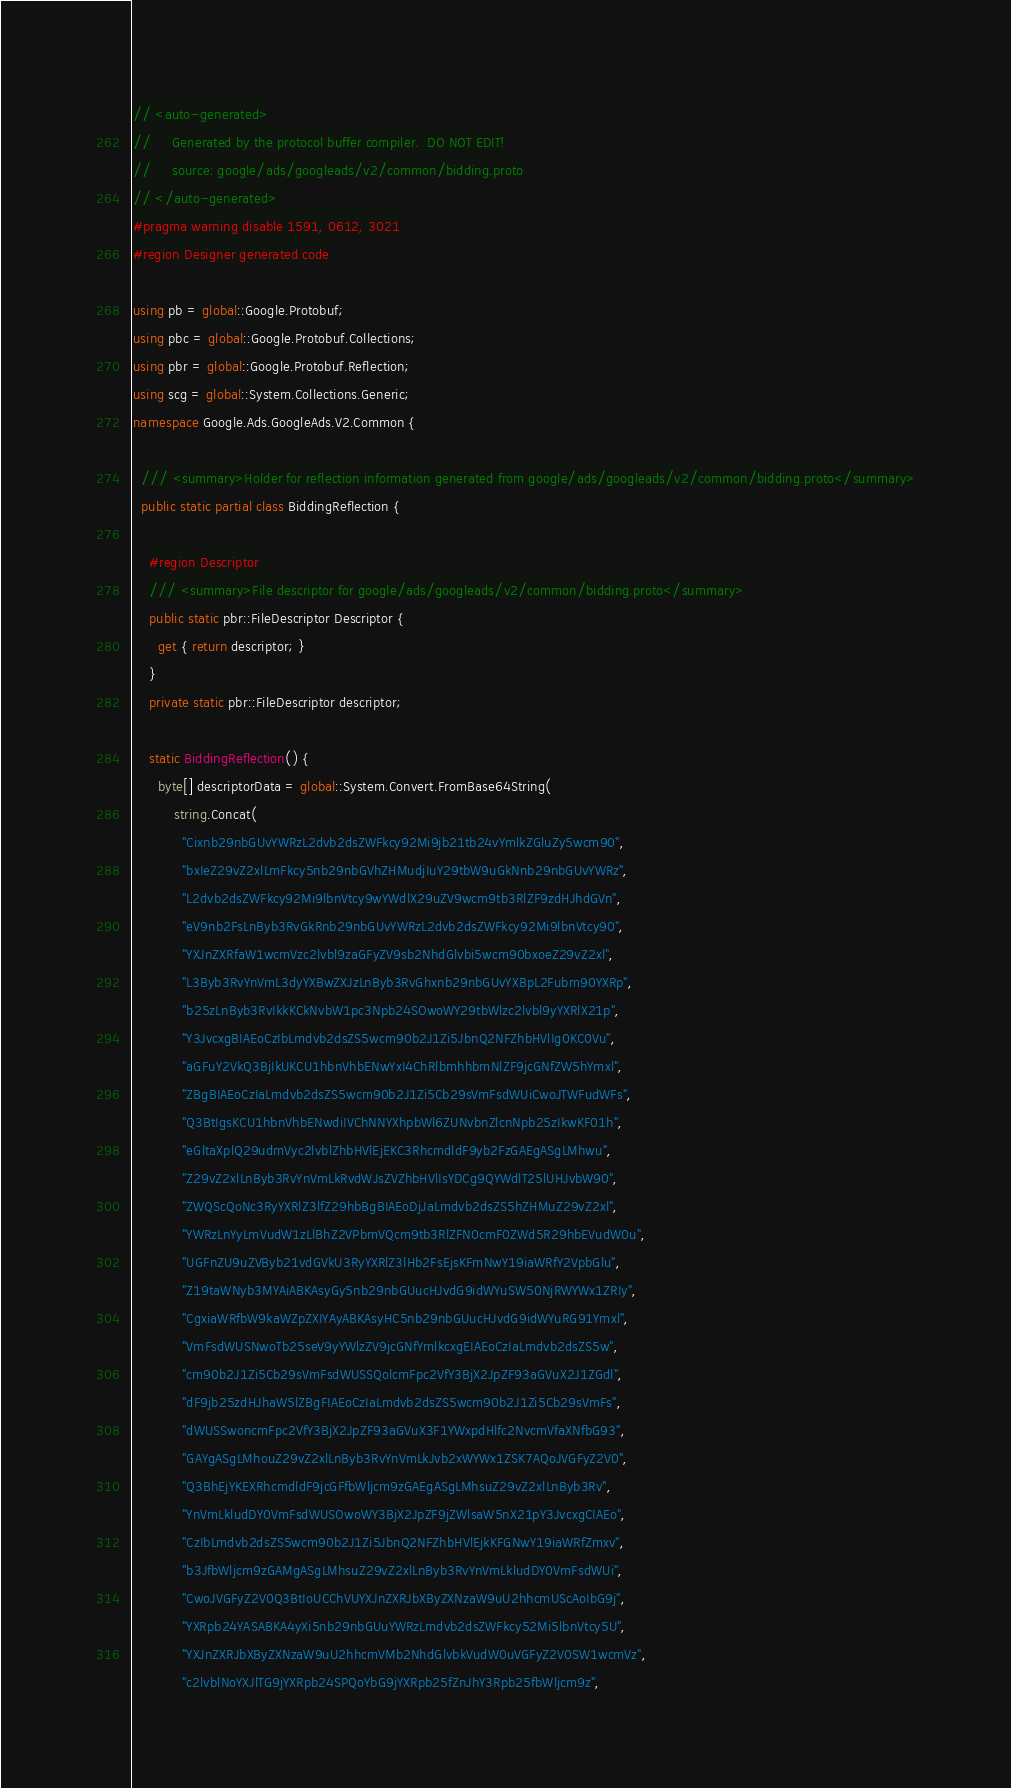Convert code to text. <code><loc_0><loc_0><loc_500><loc_500><_C#_>// <auto-generated>
//     Generated by the protocol buffer compiler.  DO NOT EDIT!
//     source: google/ads/googleads/v2/common/bidding.proto
// </auto-generated>
#pragma warning disable 1591, 0612, 3021
#region Designer generated code

using pb = global::Google.Protobuf;
using pbc = global::Google.Protobuf.Collections;
using pbr = global::Google.Protobuf.Reflection;
using scg = global::System.Collections.Generic;
namespace Google.Ads.GoogleAds.V2.Common {

  /// <summary>Holder for reflection information generated from google/ads/googleads/v2/common/bidding.proto</summary>
  public static partial class BiddingReflection {

    #region Descriptor
    /// <summary>File descriptor for google/ads/googleads/v2/common/bidding.proto</summary>
    public static pbr::FileDescriptor Descriptor {
      get { return descriptor; }
    }
    private static pbr::FileDescriptor descriptor;

    static BiddingReflection() {
      byte[] descriptorData = global::System.Convert.FromBase64String(
          string.Concat(
            "Cixnb29nbGUvYWRzL2dvb2dsZWFkcy92Mi9jb21tb24vYmlkZGluZy5wcm90",
            "bxIeZ29vZ2xlLmFkcy5nb29nbGVhZHMudjIuY29tbW9uGkNnb29nbGUvYWRz",
            "L2dvb2dsZWFkcy92Mi9lbnVtcy9wYWdlX29uZV9wcm9tb3RlZF9zdHJhdGVn",
            "eV9nb2FsLnByb3RvGkRnb29nbGUvYWRzL2dvb2dsZWFkcy92Mi9lbnVtcy90",
            "YXJnZXRfaW1wcmVzc2lvbl9zaGFyZV9sb2NhdGlvbi5wcm90bxoeZ29vZ2xl",
            "L3Byb3RvYnVmL3dyYXBwZXJzLnByb3RvGhxnb29nbGUvYXBpL2Fubm90YXRp",
            "b25zLnByb3RvIkkKCkNvbW1pc3Npb24SOwoWY29tbWlzc2lvbl9yYXRlX21p",
            "Y3JvcxgBIAEoCzIbLmdvb2dsZS5wcm90b2J1Zi5JbnQ2NFZhbHVlIg0KC0Vu",
            "aGFuY2VkQ3BjIkUKCU1hbnVhbENwYxI4ChRlbmhhbmNlZF9jcGNfZW5hYmxl",
            "ZBgBIAEoCzIaLmdvb2dsZS5wcm90b2J1Zi5Cb29sVmFsdWUiCwoJTWFudWFs",
            "Q3BtIgsKCU1hbnVhbENwdiIVChNNYXhpbWl6ZUNvbnZlcnNpb25zIkwKF01h",
            "eGltaXplQ29udmVyc2lvblZhbHVlEjEKC3RhcmdldF9yb2FzGAEgASgLMhwu",
            "Z29vZ2xlLnByb3RvYnVmLkRvdWJsZVZhbHVlIsYDCg9QYWdlT25lUHJvbW90",
            "ZWQScQoNc3RyYXRlZ3lfZ29hbBgBIAEoDjJaLmdvb2dsZS5hZHMuZ29vZ2xl",
            "YWRzLnYyLmVudW1zLlBhZ2VPbmVQcm9tb3RlZFN0cmF0ZWd5R29hbEVudW0u",
            "UGFnZU9uZVByb21vdGVkU3RyYXRlZ3lHb2FsEjsKFmNwY19iaWRfY2VpbGlu",
            "Z19taWNyb3MYAiABKAsyGy5nb29nbGUucHJvdG9idWYuSW50NjRWYWx1ZRIy",
            "CgxiaWRfbW9kaWZpZXIYAyABKAsyHC5nb29nbGUucHJvdG9idWYuRG91Ymxl",
            "VmFsdWUSNwoTb25seV9yYWlzZV9jcGNfYmlkcxgEIAEoCzIaLmdvb2dsZS5w",
            "cm90b2J1Zi5Cb29sVmFsdWUSSQolcmFpc2VfY3BjX2JpZF93aGVuX2J1ZGdl",
            "dF9jb25zdHJhaW5lZBgFIAEoCzIaLmdvb2dsZS5wcm90b2J1Zi5Cb29sVmFs",
            "dWUSSwoncmFpc2VfY3BjX2JpZF93aGVuX3F1YWxpdHlfc2NvcmVfaXNfbG93",
            "GAYgASgLMhouZ29vZ2xlLnByb3RvYnVmLkJvb2xWYWx1ZSK7AQoJVGFyZ2V0",
            "Q3BhEjYKEXRhcmdldF9jcGFfbWljcm9zGAEgASgLMhsuZ29vZ2xlLnByb3Rv",
            "YnVmLkludDY0VmFsdWUSOwoWY3BjX2JpZF9jZWlsaW5nX21pY3JvcxgCIAEo",
            "CzIbLmdvb2dsZS5wcm90b2J1Zi5JbnQ2NFZhbHVlEjkKFGNwY19iaWRfZmxv",
            "b3JfbWljcm9zGAMgASgLMhsuZ29vZ2xlLnByb3RvYnVmLkludDY0VmFsdWUi",
            "CwoJVGFyZ2V0Q3BtIoUCChVUYXJnZXRJbXByZXNzaW9uU2hhcmUScAoIbG9j",
            "YXRpb24YASABKA4yXi5nb29nbGUuYWRzLmdvb2dsZWFkcy52Mi5lbnVtcy5U",
            "YXJnZXRJbXByZXNzaW9uU2hhcmVMb2NhdGlvbkVudW0uVGFyZ2V0SW1wcmVz",
            "c2lvblNoYXJlTG9jYXRpb24SPQoYbG9jYXRpb25fZnJhY3Rpb25fbWljcm9z",</code> 